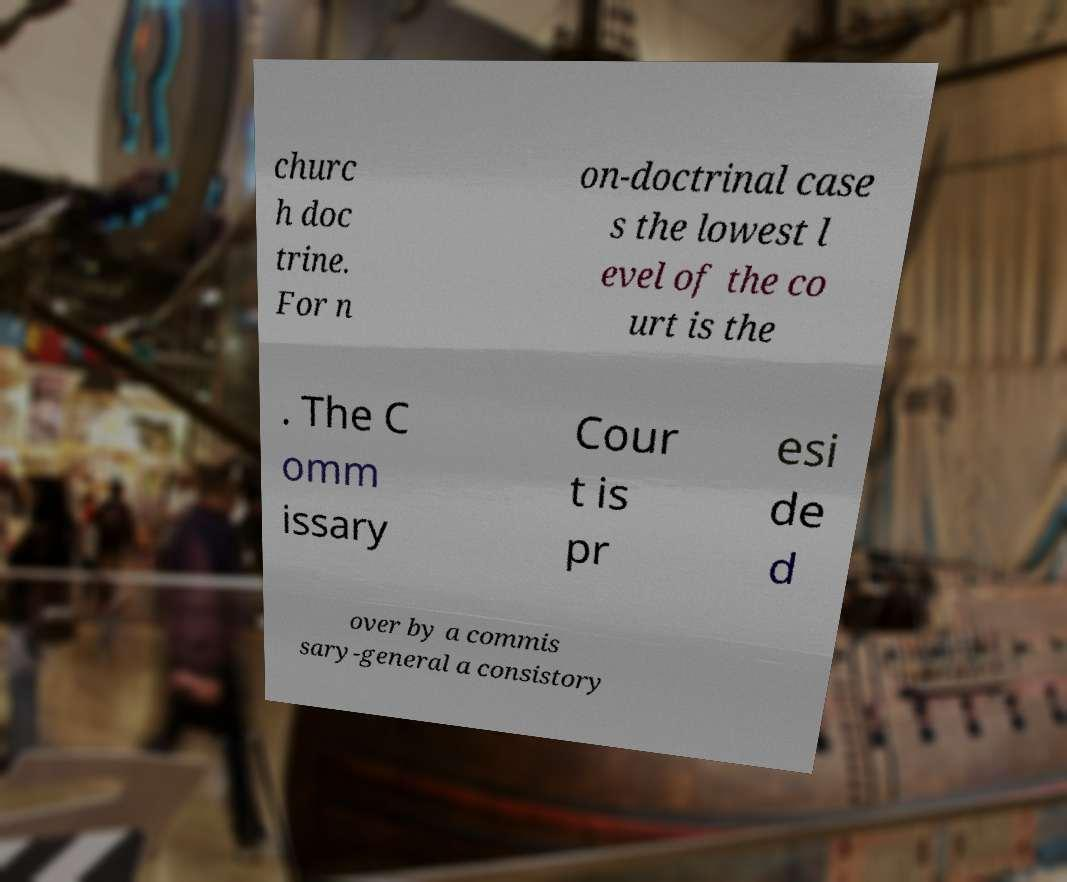There's text embedded in this image that I need extracted. Can you transcribe it verbatim? churc h doc trine. For n on-doctrinal case s the lowest l evel of the co urt is the . The C omm issary Cour t is pr esi de d over by a commis sary-general a consistory 